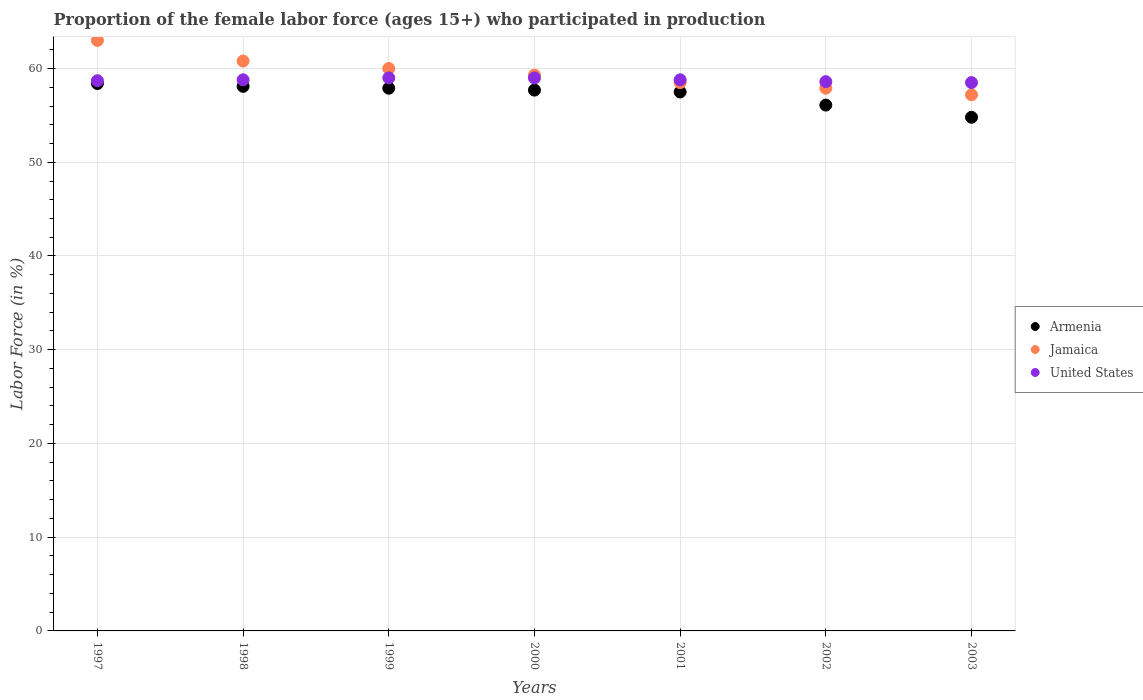Is the number of dotlines equal to the number of legend labels?
Your response must be concise. Yes. What is the proportion of the female labor force who participated in production in United States in 2003?
Your response must be concise. 58.5. Across all years, what is the maximum proportion of the female labor force who participated in production in United States?
Ensure brevity in your answer.  59. Across all years, what is the minimum proportion of the female labor force who participated in production in Armenia?
Your answer should be very brief. 54.8. In which year was the proportion of the female labor force who participated in production in United States maximum?
Your response must be concise. 1999. In which year was the proportion of the female labor force who participated in production in Jamaica minimum?
Keep it short and to the point. 2003. What is the total proportion of the female labor force who participated in production in United States in the graph?
Your response must be concise. 411.4. What is the difference between the proportion of the female labor force who participated in production in Armenia in 1998 and that in 1999?
Provide a succinct answer. 0.2. What is the difference between the proportion of the female labor force who participated in production in United States in 1997 and the proportion of the female labor force who participated in production in Jamaica in 1999?
Give a very brief answer. -1.3. What is the average proportion of the female labor force who participated in production in United States per year?
Provide a short and direct response. 58.77. In the year 1997, what is the difference between the proportion of the female labor force who participated in production in Jamaica and proportion of the female labor force who participated in production in Armenia?
Keep it short and to the point. 4.6. What is the ratio of the proportion of the female labor force who participated in production in United States in 1998 to that in 2000?
Provide a succinct answer. 1. Is the proportion of the female labor force who participated in production in Armenia in 1998 less than that in 2001?
Give a very brief answer. No. What is the difference between the highest and the second highest proportion of the female labor force who participated in production in Armenia?
Your answer should be compact. 0.3. What is the difference between the highest and the lowest proportion of the female labor force who participated in production in Armenia?
Your response must be concise. 3.6. In how many years, is the proportion of the female labor force who participated in production in United States greater than the average proportion of the female labor force who participated in production in United States taken over all years?
Provide a succinct answer. 4. Is the sum of the proportion of the female labor force who participated in production in Armenia in 1997 and 2002 greater than the maximum proportion of the female labor force who participated in production in United States across all years?
Your answer should be very brief. Yes. Does the proportion of the female labor force who participated in production in Jamaica monotonically increase over the years?
Your answer should be compact. No. Is the proportion of the female labor force who participated in production in United States strictly greater than the proportion of the female labor force who participated in production in Armenia over the years?
Your answer should be compact. Yes. Is the proportion of the female labor force who participated in production in United States strictly less than the proportion of the female labor force who participated in production in Jamaica over the years?
Your response must be concise. No. What is the difference between two consecutive major ticks on the Y-axis?
Your response must be concise. 10. Does the graph contain any zero values?
Keep it short and to the point. No. Does the graph contain grids?
Your answer should be compact. Yes. Where does the legend appear in the graph?
Your response must be concise. Center right. What is the title of the graph?
Offer a very short reply. Proportion of the female labor force (ages 15+) who participated in production. What is the label or title of the Y-axis?
Keep it short and to the point. Labor Force (in %). What is the Labor Force (in %) of Armenia in 1997?
Provide a succinct answer. 58.4. What is the Labor Force (in %) in Jamaica in 1997?
Your response must be concise. 63. What is the Labor Force (in %) in United States in 1997?
Your answer should be compact. 58.7. What is the Labor Force (in %) of Armenia in 1998?
Your answer should be compact. 58.1. What is the Labor Force (in %) of Jamaica in 1998?
Make the answer very short. 60.8. What is the Labor Force (in %) of United States in 1998?
Your response must be concise. 58.8. What is the Labor Force (in %) in Armenia in 1999?
Provide a succinct answer. 57.9. What is the Labor Force (in %) in Jamaica in 1999?
Offer a very short reply. 60. What is the Labor Force (in %) in Armenia in 2000?
Offer a very short reply. 57.7. What is the Labor Force (in %) of Jamaica in 2000?
Keep it short and to the point. 59.3. What is the Labor Force (in %) of Armenia in 2001?
Give a very brief answer. 57.5. What is the Labor Force (in %) of Jamaica in 2001?
Provide a short and direct response. 58.5. What is the Labor Force (in %) in United States in 2001?
Provide a succinct answer. 58.8. What is the Labor Force (in %) in Armenia in 2002?
Keep it short and to the point. 56.1. What is the Labor Force (in %) in Jamaica in 2002?
Keep it short and to the point. 57.9. What is the Labor Force (in %) in United States in 2002?
Ensure brevity in your answer.  58.6. What is the Labor Force (in %) of Armenia in 2003?
Ensure brevity in your answer.  54.8. What is the Labor Force (in %) of Jamaica in 2003?
Keep it short and to the point. 57.2. What is the Labor Force (in %) in United States in 2003?
Provide a short and direct response. 58.5. Across all years, what is the maximum Labor Force (in %) in Armenia?
Your response must be concise. 58.4. Across all years, what is the minimum Labor Force (in %) in Armenia?
Offer a terse response. 54.8. Across all years, what is the minimum Labor Force (in %) of Jamaica?
Your answer should be very brief. 57.2. Across all years, what is the minimum Labor Force (in %) in United States?
Your answer should be very brief. 58.5. What is the total Labor Force (in %) of Armenia in the graph?
Offer a terse response. 400.5. What is the total Labor Force (in %) in Jamaica in the graph?
Provide a succinct answer. 416.7. What is the total Labor Force (in %) in United States in the graph?
Your response must be concise. 411.4. What is the difference between the Labor Force (in %) in Jamaica in 1997 and that in 1998?
Your response must be concise. 2.2. What is the difference between the Labor Force (in %) of United States in 1997 and that in 1998?
Your answer should be compact. -0.1. What is the difference between the Labor Force (in %) of Armenia in 1997 and that in 1999?
Your answer should be very brief. 0.5. What is the difference between the Labor Force (in %) in Armenia in 1997 and that in 2000?
Provide a short and direct response. 0.7. What is the difference between the Labor Force (in %) of United States in 1997 and that in 2001?
Provide a short and direct response. -0.1. What is the difference between the Labor Force (in %) in Armenia in 1997 and that in 2003?
Give a very brief answer. 3.6. What is the difference between the Labor Force (in %) in United States in 1997 and that in 2003?
Your answer should be very brief. 0.2. What is the difference between the Labor Force (in %) of Armenia in 1998 and that in 1999?
Offer a terse response. 0.2. What is the difference between the Labor Force (in %) of United States in 1998 and that in 2000?
Your response must be concise. -0.2. What is the difference between the Labor Force (in %) of Armenia in 1998 and that in 2001?
Provide a short and direct response. 0.6. What is the difference between the Labor Force (in %) of Armenia in 1998 and that in 2002?
Give a very brief answer. 2. What is the difference between the Labor Force (in %) in Armenia in 1998 and that in 2003?
Provide a short and direct response. 3.3. What is the difference between the Labor Force (in %) in Jamaica in 1998 and that in 2003?
Offer a terse response. 3.6. What is the difference between the Labor Force (in %) of United States in 1998 and that in 2003?
Offer a very short reply. 0.3. What is the difference between the Labor Force (in %) of Armenia in 1999 and that in 2000?
Provide a succinct answer. 0.2. What is the difference between the Labor Force (in %) in Jamaica in 1999 and that in 2000?
Provide a short and direct response. 0.7. What is the difference between the Labor Force (in %) of United States in 1999 and that in 2000?
Ensure brevity in your answer.  0. What is the difference between the Labor Force (in %) in Jamaica in 1999 and that in 2001?
Provide a succinct answer. 1.5. What is the difference between the Labor Force (in %) in United States in 1999 and that in 2001?
Offer a terse response. 0.2. What is the difference between the Labor Force (in %) of United States in 1999 and that in 2002?
Ensure brevity in your answer.  0.4. What is the difference between the Labor Force (in %) of Armenia in 1999 and that in 2003?
Your answer should be very brief. 3.1. What is the difference between the Labor Force (in %) of United States in 1999 and that in 2003?
Provide a short and direct response. 0.5. What is the difference between the Labor Force (in %) of Armenia in 2000 and that in 2001?
Offer a very short reply. 0.2. What is the difference between the Labor Force (in %) of Jamaica in 2000 and that in 2001?
Your answer should be compact. 0.8. What is the difference between the Labor Force (in %) of Armenia in 2000 and that in 2002?
Provide a succinct answer. 1.6. What is the difference between the Labor Force (in %) in Jamaica in 2000 and that in 2002?
Keep it short and to the point. 1.4. What is the difference between the Labor Force (in %) of United States in 2000 and that in 2002?
Ensure brevity in your answer.  0.4. What is the difference between the Labor Force (in %) in United States in 2000 and that in 2003?
Offer a very short reply. 0.5. What is the difference between the Labor Force (in %) of Armenia in 2001 and that in 2002?
Offer a terse response. 1.4. What is the difference between the Labor Force (in %) of Armenia in 2002 and that in 2003?
Your answer should be very brief. 1.3. What is the difference between the Labor Force (in %) in United States in 2002 and that in 2003?
Provide a short and direct response. 0.1. What is the difference between the Labor Force (in %) in Armenia in 1997 and the Labor Force (in %) in Jamaica in 1998?
Your answer should be very brief. -2.4. What is the difference between the Labor Force (in %) of Jamaica in 1997 and the Labor Force (in %) of United States in 1998?
Offer a very short reply. 4.2. What is the difference between the Labor Force (in %) of Armenia in 1997 and the Labor Force (in %) of Jamaica in 1999?
Ensure brevity in your answer.  -1.6. What is the difference between the Labor Force (in %) of Armenia in 1997 and the Labor Force (in %) of United States in 1999?
Give a very brief answer. -0.6. What is the difference between the Labor Force (in %) in Jamaica in 1997 and the Labor Force (in %) in United States in 1999?
Provide a succinct answer. 4. What is the difference between the Labor Force (in %) of Armenia in 1997 and the Labor Force (in %) of United States in 2000?
Offer a terse response. -0.6. What is the difference between the Labor Force (in %) of Armenia in 1997 and the Labor Force (in %) of Jamaica in 2001?
Offer a very short reply. -0.1. What is the difference between the Labor Force (in %) of Armenia in 1997 and the Labor Force (in %) of United States in 2001?
Offer a very short reply. -0.4. What is the difference between the Labor Force (in %) of Armenia in 1997 and the Labor Force (in %) of Jamaica in 2003?
Your answer should be compact. 1.2. What is the difference between the Labor Force (in %) in Armenia in 1997 and the Labor Force (in %) in United States in 2003?
Provide a short and direct response. -0.1. What is the difference between the Labor Force (in %) in Armenia in 1998 and the Labor Force (in %) in Jamaica in 1999?
Your response must be concise. -1.9. What is the difference between the Labor Force (in %) in Jamaica in 1998 and the Labor Force (in %) in United States in 1999?
Your response must be concise. 1.8. What is the difference between the Labor Force (in %) of Armenia in 1998 and the Labor Force (in %) of United States in 2000?
Keep it short and to the point. -0.9. What is the difference between the Labor Force (in %) in Jamaica in 1998 and the Labor Force (in %) in United States in 2000?
Offer a very short reply. 1.8. What is the difference between the Labor Force (in %) in Armenia in 1998 and the Labor Force (in %) in United States in 2001?
Give a very brief answer. -0.7. What is the difference between the Labor Force (in %) in Jamaica in 1998 and the Labor Force (in %) in United States in 2001?
Make the answer very short. 2. What is the difference between the Labor Force (in %) of Armenia in 1998 and the Labor Force (in %) of United States in 2003?
Give a very brief answer. -0.4. What is the difference between the Labor Force (in %) of Jamaica in 1999 and the Labor Force (in %) of United States in 2000?
Ensure brevity in your answer.  1. What is the difference between the Labor Force (in %) of Jamaica in 1999 and the Labor Force (in %) of United States in 2001?
Keep it short and to the point. 1.2. What is the difference between the Labor Force (in %) of Armenia in 1999 and the Labor Force (in %) of United States in 2002?
Offer a terse response. -0.7. What is the difference between the Labor Force (in %) in Jamaica in 1999 and the Labor Force (in %) in United States in 2002?
Offer a very short reply. 1.4. What is the difference between the Labor Force (in %) in Armenia in 1999 and the Labor Force (in %) in Jamaica in 2003?
Offer a very short reply. 0.7. What is the difference between the Labor Force (in %) of Jamaica in 1999 and the Labor Force (in %) of United States in 2003?
Provide a short and direct response. 1.5. What is the difference between the Labor Force (in %) in Armenia in 2000 and the Labor Force (in %) in Jamaica in 2001?
Ensure brevity in your answer.  -0.8. What is the difference between the Labor Force (in %) in Armenia in 2000 and the Labor Force (in %) in Jamaica in 2002?
Give a very brief answer. -0.2. What is the difference between the Labor Force (in %) of Armenia in 2000 and the Labor Force (in %) of United States in 2002?
Offer a terse response. -0.9. What is the difference between the Labor Force (in %) of Jamaica in 2000 and the Labor Force (in %) of United States in 2002?
Your answer should be very brief. 0.7. What is the difference between the Labor Force (in %) in Armenia in 2000 and the Labor Force (in %) in United States in 2003?
Offer a terse response. -0.8. What is the difference between the Labor Force (in %) of Jamaica in 2000 and the Labor Force (in %) of United States in 2003?
Your response must be concise. 0.8. What is the difference between the Labor Force (in %) of Armenia in 2001 and the Labor Force (in %) of Jamaica in 2002?
Give a very brief answer. -0.4. What is the difference between the Labor Force (in %) of Jamaica in 2001 and the Labor Force (in %) of United States in 2002?
Give a very brief answer. -0.1. What is the difference between the Labor Force (in %) in Jamaica in 2001 and the Labor Force (in %) in United States in 2003?
Provide a short and direct response. 0. What is the difference between the Labor Force (in %) in Armenia in 2002 and the Labor Force (in %) in Jamaica in 2003?
Your response must be concise. -1.1. What is the difference between the Labor Force (in %) of Armenia in 2002 and the Labor Force (in %) of United States in 2003?
Ensure brevity in your answer.  -2.4. What is the average Labor Force (in %) in Armenia per year?
Your response must be concise. 57.21. What is the average Labor Force (in %) of Jamaica per year?
Give a very brief answer. 59.53. What is the average Labor Force (in %) in United States per year?
Offer a terse response. 58.77. In the year 1997, what is the difference between the Labor Force (in %) in Armenia and Labor Force (in %) in United States?
Offer a very short reply. -0.3. In the year 1997, what is the difference between the Labor Force (in %) of Jamaica and Labor Force (in %) of United States?
Provide a succinct answer. 4.3. In the year 1998, what is the difference between the Labor Force (in %) in Jamaica and Labor Force (in %) in United States?
Make the answer very short. 2. In the year 2000, what is the difference between the Labor Force (in %) of Armenia and Labor Force (in %) of United States?
Your response must be concise. -1.3. In the year 2001, what is the difference between the Labor Force (in %) in Jamaica and Labor Force (in %) in United States?
Keep it short and to the point. -0.3. In the year 2002, what is the difference between the Labor Force (in %) in Armenia and Labor Force (in %) in Jamaica?
Your answer should be very brief. -1.8. In the year 2002, what is the difference between the Labor Force (in %) in Jamaica and Labor Force (in %) in United States?
Keep it short and to the point. -0.7. In the year 2003, what is the difference between the Labor Force (in %) in Armenia and Labor Force (in %) in Jamaica?
Give a very brief answer. -2.4. What is the ratio of the Labor Force (in %) in Jamaica in 1997 to that in 1998?
Offer a very short reply. 1.04. What is the ratio of the Labor Force (in %) of Armenia in 1997 to that in 1999?
Keep it short and to the point. 1.01. What is the ratio of the Labor Force (in %) of United States in 1997 to that in 1999?
Provide a succinct answer. 0.99. What is the ratio of the Labor Force (in %) in Armenia in 1997 to that in 2000?
Offer a terse response. 1.01. What is the ratio of the Labor Force (in %) of Jamaica in 1997 to that in 2000?
Offer a terse response. 1.06. What is the ratio of the Labor Force (in %) of United States in 1997 to that in 2000?
Provide a short and direct response. 0.99. What is the ratio of the Labor Force (in %) in Armenia in 1997 to that in 2001?
Your answer should be compact. 1.02. What is the ratio of the Labor Force (in %) of Armenia in 1997 to that in 2002?
Offer a terse response. 1.04. What is the ratio of the Labor Force (in %) in Jamaica in 1997 to that in 2002?
Offer a very short reply. 1.09. What is the ratio of the Labor Force (in %) of Armenia in 1997 to that in 2003?
Keep it short and to the point. 1.07. What is the ratio of the Labor Force (in %) of Jamaica in 1997 to that in 2003?
Offer a terse response. 1.1. What is the ratio of the Labor Force (in %) of United States in 1997 to that in 2003?
Provide a short and direct response. 1. What is the ratio of the Labor Force (in %) of Armenia in 1998 to that in 1999?
Ensure brevity in your answer.  1. What is the ratio of the Labor Force (in %) in Jamaica in 1998 to that in 1999?
Provide a succinct answer. 1.01. What is the ratio of the Labor Force (in %) in Jamaica in 1998 to that in 2000?
Keep it short and to the point. 1.03. What is the ratio of the Labor Force (in %) of United States in 1998 to that in 2000?
Your response must be concise. 1. What is the ratio of the Labor Force (in %) in Armenia in 1998 to that in 2001?
Your answer should be compact. 1.01. What is the ratio of the Labor Force (in %) in Jamaica in 1998 to that in 2001?
Provide a succinct answer. 1.04. What is the ratio of the Labor Force (in %) in United States in 1998 to that in 2001?
Your answer should be very brief. 1. What is the ratio of the Labor Force (in %) in Armenia in 1998 to that in 2002?
Offer a very short reply. 1.04. What is the ratio of the Labor Force (in %) in Jamaica in 1998 to that in 2002?
Your response must be concise. 1.05. What is the ratio of the Labor Force (in %) in United States in 1998 to that in 2002?
Your answer should be very brief. 1. What is the ratio of the Labor Force (in %) of Armenia in 1998 to that in 2003?
Keep it short and to the point. 1.06. What is the ratio of the Labor Force (in %) of Jamaica in 1998 to that in 2003?
Provide a succinct answer. 1.06. What is the ratio of the Labor Force (in %) of Armenia in 1999 to that in 2000?
Make the answer very short. 1. What is the ratio of the Labor Force (in %) of Jamaica in 1999 to that in 2000?
Your answer should be compact. 1.01. What is the ratio of the Labor Force (in %) of United States in 1999 to that in 2000?
Make the answer very short. 1. What is the ratio of the Labor Force (in %) in Armenia in 1999 to that in 2001?
Provide a short and direct response. 1.01. What is the ratio of the Labor Force (in %) of Jamaica in 1999 to that in 2001?
Make the answer very short. 1.03. What is the ratio of the Labor Force (in %) in Armenia in 1999 to that in 2002?
Your answer should be compact. 1.03. What is the ratio of the Labor Force (in %) of Jamaica in 1999 to that in 2002?
Keep it short and to the point. 1.04. What is the ratio of the Labor Force (in %) in United States in 1999 to that in 2002?
Give a very brief answer. 1.01. What is the ratio of the Labor Force (in %) of Armenia in 1999 to that in 2003?
Offer a very short reply. 1.06. What is the ratio of the Labor Force (in %) in Jamaica in 1999 to that in 2003?
Provide a short and direct response. 1.05. What is the ratio of the Labor Force (in %) in United States in 1999 to that in 2003?
Offer a terse response. 1.01. What is the ratio of the Labor Force (in %) in Armenia in 2000 to that in 2001?
Keep it short and to the point. 1. What is the ratio of the Labor Force (in %) of Jamaica in 2000 to that in 2001?
Provide a succinct answer. 1.01. What is the ratio of the Labor Force (in %) in Armenia in 2000 to that in 2002?
Provide a short and direct response. 1.03. What is the ratio of the Labor Force (in %) of Jamaica in 2000 to that in 2002?
Provide a short and direct response. 1.02. What is the ratio of the Labor Force (in %) of United States in 2000 to that in 2002?
Your answer should be very brief. 1.01. What is the ratio of the Labor Force (in %) in Armenia in 2000 to that in 2003?
Offer a very short reply. 1.05. What is the ratio of the Labor Force (in %) of Jamaica in 2000 to that in 2003?
Give a very brief answer. 1.04. What is the ratio of the Labor Force (in %) of United States in 2000 to that in 2003?
Your answer should be compact. 1.01. What is the ratio of the Labor Force (in %) of Jamaica in 2001 to that in 2002?
Provide a succinct answer. 1.01. What is the ratio of the Labor Force (in %) in United States in 2001 to that in 2002?
Offer a very short reply. 1. What is the ratio of the Labor Force (in %) of Armenia in 2001 to that in 2003?
Offer a very short reply. 1.05. What is the ratio of the Labor Force (in %) in Jamaica in 2001 to that in 2003?
Your answer should be very brief. 1.02. What is the ratio of the Labor Force (in %) of Armenia in 2002 to that in 2003?
Offer a terse response. 1.02. What is the ratio of the Labor Force (in %) of Jamaica in 2002 to that in 2003?
Offer a very short reply. 1.01. What is the ratio of the Labor Force (in %) in United States in 2002 to that in 2003?
Offer a very short reply. 1. What is the difference between the highest and the second highest Labor Force (in %) of Armenia?
Ensure brevity in your answer.  0.3. What is the difference between the highest and the second highest Labor Force (in %) in Jamaica?
Ensure brevity in your answer.  2.2. What is the difference between the highest and the second highest Labor Force (in %) in United States?
Your answer should be compact. 0. What is the difference between the highest and the lowest Labor Force (in %) in Armenia?
Your answer should be compact. 3.6. 